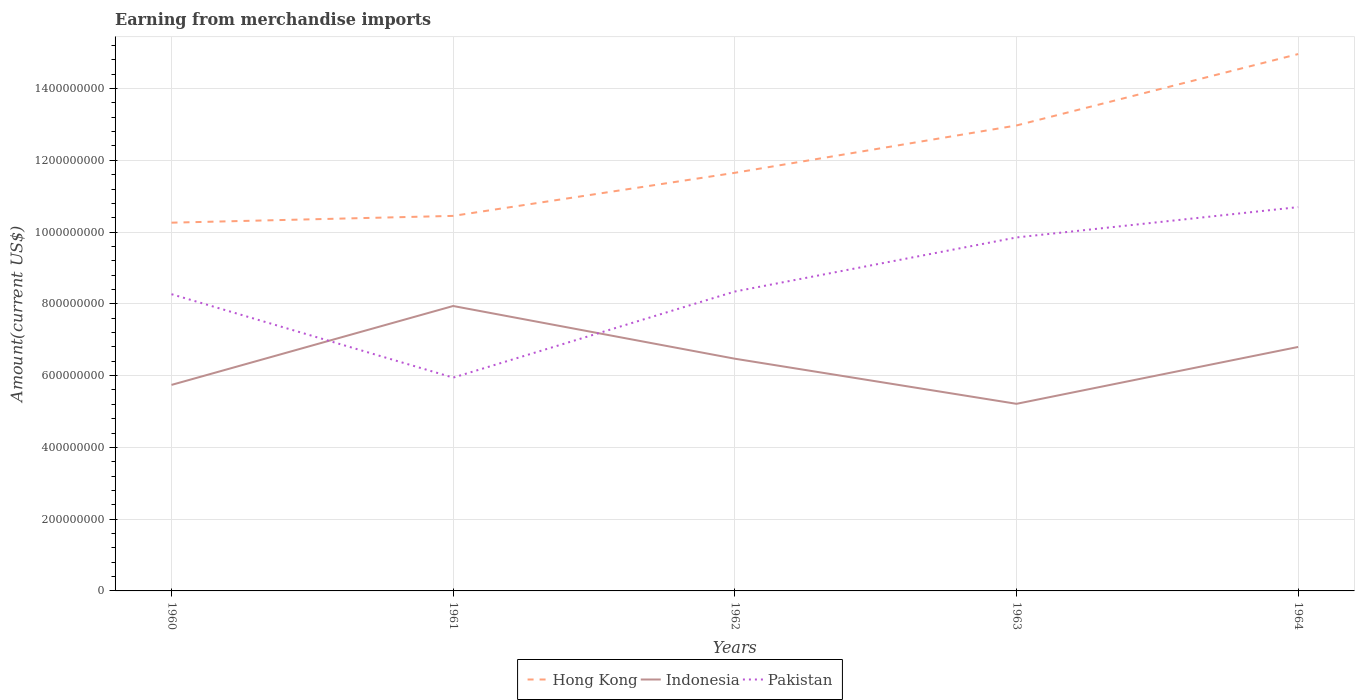How many different coloured lines are there?
Offer a terse response. 3. Does the line corresponding to Pakistan intersect with the line corresponding to Indonesia?
Offer a terse response. Yes. Is the number of lines equal to the number of legend labels?
Make the answer very short. Yes. Across all years, what is the maximum amount earned from merchandise imports in Hong Kong?
Your answer should be compact. 1.03e+09. In which year was the amount earned from merchandise imports in Hong Kong maximum?
Make the answer very short. 1960. What is the total amount earned from merchandise imports in Hong Kong in the graph?
Offer a terse response. -1.32e+08. What is the difference between the highest and the second highest amount earned from merchandise imports in Hong Kong?
Make the answer very short. 4.70e+08. Is the amount earned from merchandise imports in Indonesia strictly greater than the amount earned from merchandise imports in Hong Kong over the years?
Your answer should be compact. Yes. How many years are there in the graph?
Offer a very short reply. 5. What is the difference between two consecutive major ticks on the Y-axis?
Offer a terse response. 2.00e+08. Are the values on the major ticks of Y-axis written in scientific E-notation?
Offer a very short reply. No. Does the graph contain any zero values?
Keep it short and to the point. No. How many legend labels are there?
Offer a terse response. 3. How are the legend labels stacked?
Give a very brief answer. Horizontal. What is the title of the graph?
Offer a terse response. Earning from merchandise imports. What is the label or title of the Y-axis?
Your answer should be very brief. Amount(current US$). What is the Amount(current US$) in Hong Kong in 1960?
Keep it short and to the point. 1.03e+09. What is the Amount(current US$) in Indonesia in 1960?
Keep it short and to the point. 5.74e+08. What is the Amount(current US$) in Pakistan in 1960?
Offer a terse response. 8.27e+08. What is the Amount(current US$) of Hong Kong in 1961?
Keep it short and to the point. 1.05e+09. What is the Amount(current US$) of Indonesia in 1961?
Your answer should be very brief. 7.94e+08. What is the Amount(current US$) in Pakistan in 1961?
Make the answer very short. 5.94e+08. What is the Amount(current US$) of Hong Kong in 1962?
Your response must be concise. 1.17e+09. What is the Amount(current US$) in Indonesia in 1962?
Ensure brevity in your answer.  6.47e+08. What is the Amount(current US$) in Pakistan in 1962?
Your answer should be very brief. 8.34e+08. What is the Amount(current US$) in Hong Kong in 1963?
Offer a terse response. 1.30e+09. What is the Amount(current US$) of Indonesia in 1963?
Provide a short and direct response. 5.21e+08. What is the Amount(current US$) in Pakistan in 1963?
Your response must be concise. 9.85e+08. What is the Amount(current US$) of Hong Kong in 1964?
Ensure brevity in your answer.  1.50e+09. What is the Amount(current US$) of Indonesia in 1964?
Your response must be concise. 6.80e+08. What is the Amount(current US$) in Pakistan in 1964?
Provide a succinct answer. 1.07e+09. Across all years, what is the maximum Amount(current US$) of Hong Kong?
Ensure brevity in your answer.  1.50e+09. Across all years, what is the maximum Amount(current US$) of Indonesia?
Offer a terse response. 7.94e+08. Across all years, what is the maximum Amount(current US$) of Pakistan?
Your response must be concise. 1.07e+09. Across all years, what is the minimum Amount(current US$) of Hong Kong?
Offer a terse response. 1.03e+09. Across all years, what is the minimum Amount(current US$) in Indonesia?
Keep it short and to the point. 5.21e+08. Across all years, what is the minimum Amount(current US$) of Pakistan?
Provide a succinct answer. 5.94e+08. What is the total Amount(current US$) of Hong Kong in the graph?
Provide a short and direct response. 6.03e+09. What is the total Amount(current US$) in Indonesia in the graph?
Your response must be concise. 3.22e+09. What is the total Amount(current US$) in Pakistan in the graph?
Offer a very short reply. 4.31e+09. What is the difference between the Amount(current US$) of Hong Kong in 1960 and that in 1961?
Offer a terse response. -1.89e+07. What is the difference between the Amount(current US$) in Indonesia in 1960 and that in 1961?
Keep it short and to the point. -2.20e+08. What is the difference between the Amount(current US$) in Pakistan in 1960 and that in 1961?
Provide a succinct answer. 2.33e+08. What is the difference between the Amount(current US$) of Hong Kong in 1960 and that in 1962?
Ensure brevity in your answer.  -1.39e+08. What is the difference between the Amount(current US$) of Indonesia in 1960 and that in 1962?
Your answer should be very brief. -7.30e+07. What is the difference between the Amount(current US$) in Pakistan in 1960 and that in 1962?
Keep it short and to the point. -7.41e+06. What is the difference between the Amount(current US$) in Hong Kong in 1960 and that in 1963?
Your answer should be very brief. -2.71e+08. What is the difference between the Amount(current US$) of Indonesia in 1960 and that in 1963?
Offer a terse response. 5.27e+07. What is the difference between the Amount(current US$) of Pakistan in 1960 and that in 1963?
Your answer should be very brief. -1.58e+08. What is the difference between the Amount(current US$) of Hong Kong in 1960 and that in 1964?
Ensure brevity in your answer.  -4.70e+08. What is the difference between the Amount(current US$) in Indonesia in 1960 and that in 1964?
Provide a succinct answer. -1.06e+08. What is the difference between the Amount(current US$) of Pakistan in 1960 and that in 1964?
Provide a short and direct response. -2.43e+08. What is the difference between the Amount(current US$) in Hong Kong in 1961 and that in 1962?
Provide a succinct answer. -1.20e+08. What is the difference between the Amount(current US$) of Indonesia in 1961 and that in 1962?
Provide a short and direct response. 1.47e+08. What is the difference between the Amount(current US$) in Pakistan in 1961 and that in 1962?
Keep it short and to the point. -2.40e+08. What is the difference between the Amount(current US$) in Hong Kong in 1961 and that in 1963?
Make the answer very short. -2.52e+08. What is the difference between the Amount(current US$) of Indonesia in 1961 and that in 1963?
Keep it short and to the point. 2.73e+08. What is the difference between the Amount(current US$) of Pakistan in 1961 and that in 1963?
Make the answer very short. -3.91e+08. What is the difference between the Amount(current US$) of Hong Kong in 1961 and that in 1964?
Keep it short and to the point. -4.51e+08. What is the difference between the Amount(current US$) of Indonesia in 1961 and that in 1964?
Provide a succinct answer. 1.14e+08. What is the difference between the Amount(current US$) of Pakistan in 1961 and that in 1964?
Your answer should be compact. -4.75e+08. What is the difference between the Amount(current US$) of Hong Kong in 1962 and that in 1963?
Your response must be concise. -1.32e+08. What is the difference between the Amount(current US$) in Indonesia in 1962 and that in 1963?
Provide a short and direct response. 1.26e+08. What is the difference between the Amount(current US$) of Pakistan in 1962 and that in 1963?
Your answer should be compact. -1.51e+08. What is the difference between the Amount(current US$) in Hong Kong in 1962 and that in 1964?
Ensure brevity in your answer.  -3.31e+08. What is the difference between the Amount(current US$) of Indonesia in 1962 and that in 1964?
Your response must be concise. -3.28e+07. What is the difference between the Amount(current US$) of Pakistan in 1962 and that in 1964?
Provide a short and direct response. -2.35e+08. What is the difference between the Amount(current US$) of Hong Kong in 1963 and that in 1964?
Ensure brevity in your answer.  -1.99e+08. What is the difference between the Amount(current US$) of Indonesia in 1963 and that in 1964?
Provide a short and direct response. -1.58e+08. What is the difference between the Amount(current US$) in Pakistan in 1963 and that in 1964?
Your response must be concise. -8.45e+07. What is the difference between the Amount(current US$) of Hong Kong in 1960 and the Amount(current US$) of Indonesia in 1961?
Your answer should be compact. 2.32e+08. What is the difference between the Amount(current US$) of Hong Kong in 1960 and the Amount(current US$) of Pakistan in 1961?
Ensure brevity in your answer.  4.32e+08. What is the difference between the Amount(current US$) of Indonesia in 1960 and the Amount(current US$) of Pakistan in 1961?
Provide a short and direct response. -2.03e+07. What is the difference between the Amount(current US$) of Hong Kong in 1960 and the Amount(current US$) of Indonesia in 1962?
Provide a short and direct response. 3.79e+08. What is the difference between the Amount(current US$) in Hong Kong in 1960 and the Amount(current US$) in Pakistan in 1962?
Ensure brevity in your answer.  1.92e+08. What is the difference between the Amount(current US$) in Indonesia in 1960 and the Amount(current US$) in Pakistan in 1962?
Your answer should be very brief. -2.60e+08. What is the difference between the Amount(current US$) in Hong Kong in 1960 and the Amount(current US$) in Indonesia in 1963?
Provide a succinct answer. 5.05e+08. What is the difference between the Amount(current US$) of Hong Kong in 1960 and the Amount(current US$) of Pakistan in 1963?
Your answer should be very brief. 4.12e+07. What is the difference between the Amount(current US$) in Indonesia in 1960 and the Amount(current US$) in Pakistan in 1963?
Offer a very short reply. -4.11e+08. What is the difference between the Amount(current US$) in Hong Kong in 1960 and the Amount(current US$) in Indonesia in 1964?
Your answer should be very brief. 3.46e+08. What is the difference between the Amount(current US$) of Hong Kong in 1960 and the Amount(current US$) of Pakistan in 1964?
Offer a terse response. -4.34e+07. What is the difference between the Amount(current US$) of Indonesia in 1960 and the Amount(current US$) of Pakistan in 1964?
Offer a terse response. -4.95e+08. What is the difference between the Amount(current US$) of Hong Kong in 1961 and the Amount(current US$) of Indonesia in 1962?
Your response must be concise. 3.98e+08. What is the difference between the Amount(current US$) in Hong Kong in 1961 and the Amount(current US$) in Pakistan in 1962?
Ensure brevity in your answer.  2.11e+08. What is the difference between the Amount(current US$) of Indonesia in 1961 and the Amount(current US$) of Pakistan in 1962?
Give a very brief answer. -4.03e+07. What is the difference between the Amount(current US$) in Hong Kong in 1961 and the Amount(current US$) in Indonesia in 1963?
Your response must be concise. 5.24e+08. What is the difference between the Amount(current US$) in Hong Kong in 1961 and the Amount(current US$) in Pakistan in 1963?
Your response must be concise. 6.01e+07. What is the difference between the Amount(current US$) of Indonesia in 1961 and the Amount(current US$) of Pakistan in 1963?
Give a very brief answer. -1.91e+08. What is the difference between the Amount(current US$) of Hong Kong in 1961 and the Amount(current US$) of Indonesia in 1964?
Make the answer very short. 3.65e+08. What is the difference between the Amount(current US$) in Hong Kong in 1961 and the Amount(current US$) in Pakistan in 1964?
Your answer should be very brief. -2.45e+07. What is the difference between the Amount(current US$) of Indonesia in 1961 and the Amount(current US$) of Pakistan in 1964?
Offer a terse response. -2.76e+08. What is the difference between the Amount(current US$) of Hong Kong in 1962 and the Amount(current US$) of Indonesia in 1963?
Your answer should be very brief. 6.44e+08. What is the difference between the Amount(current US$) in Hong Kong in 1962 and the Amount(current US$) in Pakistan in 1963?
Keep it short and to the point. 1.80e+08. What is the difference between the Amount(current US$) in Indonesia in 1962 and the Amount(current US$) in Pakistan in 1963?
Your answer should be very brief. -3.38e+08. What is the difference between the Amount(current US$) of Hong Kong in 1962 and the Amount(current US$) of Indonesia in 1964?
Offer a very short reply. 4.85e+08. What is the difference between the Amount(current US$) of Hong Kong in 1962 and the Amount(current US$) of Pakistan in 1964?
Keep it short and to the point. 9.56e+07. What is the difference between the Amount(current US$) of Indonesia in 1962 and the Amount(current US$) of Pakistan in 1964?
Provide a succinct answer. -4.22e+08. What is the difference between the Amount(current US$) of Hong Kong in 1963 and the Amount(current US$) of Indonesia in 1964?
Give a very brief answer. 6.17e+08. What is the difference between the Amount(current US$) in Hong Kong in 1963 and the Amount(current US$) in Pakistan in 1964?
Make the answer very short. 2.28e+08. What is the difference between the Amount(current US$) in Indonesia in 1963 and the Amount(current US$) in Pakistan in 1964?
Offer a very short reply. -5.48e+08. What is the average Amount(current US$) in Hong Kong per year?
Provide a short and direct response. 1.21e+09. What is the average Amount(current US$) in Indonesia per year?
Keep it short and to the point. 6.43e+08. What is the average Amount(current US$) in Pakistan per year?
Offer a terse response. 8.62e+08. In the year 1960, what is the difference between the Amount(current US$) of Hong Kong and Amount(current US$) of Indonesia?
Your response must be concise. 4.52e+08. In the year 1960, what is the difference between the Amount(current US$) in Hong Kong and Amount(current US$) in Pakistan?
Provide a short and direct response. 1.99e+08. In the year 1960, what is the difference between the Amount(current US$) of Indonesia and Amount(current US$) of Pakistan?
Your response must be concise. -2.53e+08. In the year 1961, what is the difference between the Amount(current US$) of Hong Kong and Amount(current US$) of Indonesia?
Provide a short and direct response. 2.51e+08. In the year 1961, what is the difference between the Amount(current US$) in Hong Kong and Amount(current US$) in Pakistan?
Your answer should be compact. 4.51e+08. In the year 1961, what is the difference between the Amount(current US$) in Indonesia and Amount(current US$) in Pakistan?
Ensure brevity in your answer.  2.00e+08. In the year 1962, what is the difference between the Amount(current US$) of Hong Kong and Amount(current US$) of Indonesia?
Your answer should be compact. 5.18e+08. In the year 1962, what is the difference between the Amount(current US$) of Hong Kong and Amount(current US$) of Pakistan?
Your response must be concise. 3.31e+08. In the year 1962, what is the difference between the Amount(current US$) in Indonesia and Amount(current US$) in Pakistan?
Offer a terse response. -1.87e+08. In the year 1963, what is the difference between the Amount(current US$) of Hong Kong and Amount(current US$) of Indonesia?
Your answer should be compact. 7.76e+08. In the year 1963, what is the difference between the Amount(current US$) in Hong Kong and Amount(current US$) in Pakistan?
Keep it short and to the point. 3.12e+08. In the year 1963, what is the difference between the Amount(current US$) of Indonesia and Amount(current US$) of Pakistan?
Offer a terse response. -4.64e+08. In the year 1964, what is the difference between the Amount(current US$) of Hong Kong and Amount(current US$) of Indonesia?
Provide a succinct answer. 8.16e+08. In the year 1964, what is the difference between the Amount(current US$) in Hong Kong and Amount(current US$) in Pakistan?
Offer a terse response. 4.27e+08. In the year 1964, what is the difference between the Amount(current US$) of Indonesia and Amount(current US$) of Pakistan?
Give a very brief answer. -3.90e+08. What is the ratio of the Amount(current US$) in Hong Kong in 1960 to that in 1961?
Keep it short and to the point. 0.98. What is the ratio of the Amount(current US$) in Indonesia in 1960 to that in 1961?
Give a very brief answer. 0.72. What is the ratio of the Amount(current US$) in Pakistan in 1960 to that in 1961?
Offer a terse response. 1.39. What is the ratio of the Amount(current US$) in Hong Kong in 1960 to that in 1962?
Keep it short and to the point. 0.88. What is the ratio of the Amount(current US$) of Indonesia in 1960 to that in 1962?
Provide a succinct answer. 0.89. What is the ratio of the Amount(current US$) of Hong Kong in 1960 to that in 1963?
Give a very brief answer. 0.79. What is the ratio of the Amount(current US$) of Indonesia in 1960 to that in 1963?
Your answer should be compact. 1.1. What is the ratio of the Amount(current US$) of Pakistan in 1960 to that in 1963?
Ensure brevity in your answer.  0.84. What is the ratio of the Amount(current US$) of Hong Kong in 1960 to that in 1964?
Offer a very short reply. 0.69. What is the ratio of the Amount(current US$) in Indonesia in 1960 to that in 1964?
Your response must be concise. 0.84. What is the ratio of the Amount(current US$) in Pakistan in 1960 to that in 1964?
Provide a short and direct response. 0.77. What is the ratio of the Amount(current US$) in Hong Kong in 1961 to that in 1962?
Provide a succinct answer. 0.9. What is the ratio of the Amount(current US$) in Indonesia in 1961 to that in 1962?
Keep it short and to the point. 1.23. What is the ratio of the Amount(current US$) of Pakistan in 1961 to that in 1962?
Keep it short and to the point. 0.71. What is the ratio of the Amount(current US$) of Hong Kong in 1961 to that in 1963?
Keep it short and to the point. 0.81. What is the ratio of the Amount(current US$) of Indonesia in 1961 to that in 1963?
Your answer should be compact. 1.52. What is the ratio of the Amount(current US$) of Pakistan in 1961 to that in 1963?
Your answer should be very brief. 0.6. What is the ratio of the Amount(current US$) of Hong Kong in 1961 to that in 1964?
Ensure brevity in your answer.  0.7. What is the ratio of the Amount(current US$) of Indonesia in 1961 to that in 1964?
Provide a short and direct response. 1.17. What is the ratio of the Amount(current US$) in Pakistan in 1961 to that in 1964?
Give a very brief answer. 0.56. What is the ratio of the Amount(current US$) of Hong Kong in 1962 to that in 1963?
Provide a succinct answer. 0.9. What is the ratio of the Amount(current US$) of Indonesia in 1962 to that in 1963?
Provide a succinct answer. 1.24. What is the ratio of the Amount(current US$) of Pakistan in 1962 to that in 1963?
Your answer should be compact. 0.85. What is the ratio of the Amount(current US$) of Hong Kong in 1962 to that in 1964?
Ensure brevity in your answer.  0.78. What is the ratio of the Amount(current US$) of Indonesia in 1962 to that in 1964?
Ensure brevity in your answer.  0.95. What is the ratio of the Amount(current US$) of Pakistan in 1962 to that in 1964?
Give a very brief answer. 0.78. What is the ratio of the Amount(current US$) of Hong Kong in 1963 to that in 1964?
Give a very brief answer. 0.87. What is the ratio of the Amount(current US$) in Indonesia in 1963 to that in 1964?
Make the answer very short. 0.77. What is the ratio of the Amount(current US$) in Pakistan in 1963 to that in 1964?
Your answer should be compact. 0.92. What is the difference between the highest and the second highest Amount(current US$) in Hong Kong?
Offer a very short reply. 1.99e+08. What is the difference between the highest and the second highest Amount(current US$) of Indonesia?
Ensure brevity in your answer.  1.14e+08. What is the difference between the highest and the second highest Amount(current US$) of Pakistan?
Provide a short and direct response. 8.45e+07. What is the difference between the highest and the lowest Amount(current US$) of Hong Kong?
Offer a very short reply. 4.70e+08. What is the difference between the highest and the lowest Amount(current US$) of Indonesia?
Provide a succinct answer. 2.73e+08. What is the difference between the highest and the lowest Amount(current US$) in Pakistan?
Ensure brevity in your answer.  4.75e+08. 